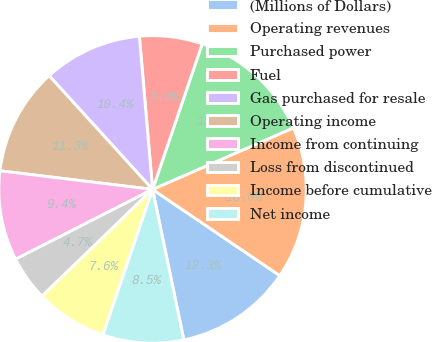<chart> <loc_0><loc_0><loc_500><loc_500><pie_chart><fcel>(Millions of Dollars)<fcel>Operating revenues<fcel>Purchased power<fcel>Fuel<fcel>Gas purchased for resale<fcel>Operating income<fcel>Income from continuing<fcel>Loss from discontinued<fcel>Income before cumulative<fcel>Net income<nl><fcel>12.26%<fcel>16.04%<fcel>13.21%<fcel>6.6%<fcel>10.38%<fcel>11.32%<fcel>9.43%<fcel>4.72%<fcel>7.55%<fcel>8.49%<nl></chart> 